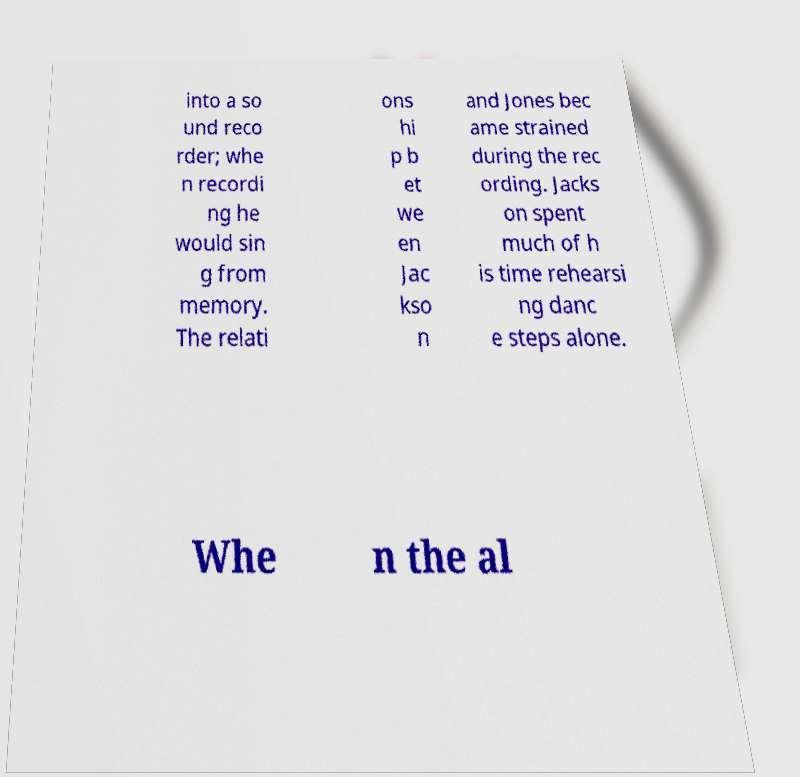Can you accurately transcribe the text from the provided image for me? into a so und reco rder; whe n recordi ng he would sin g from memory. The relati ons hi p b et we en Jac kso n and Jones bec ame strained during the rec ording. Jacks on spent much of h is time rehearsi ng danc e steps alone. Whe n the al 